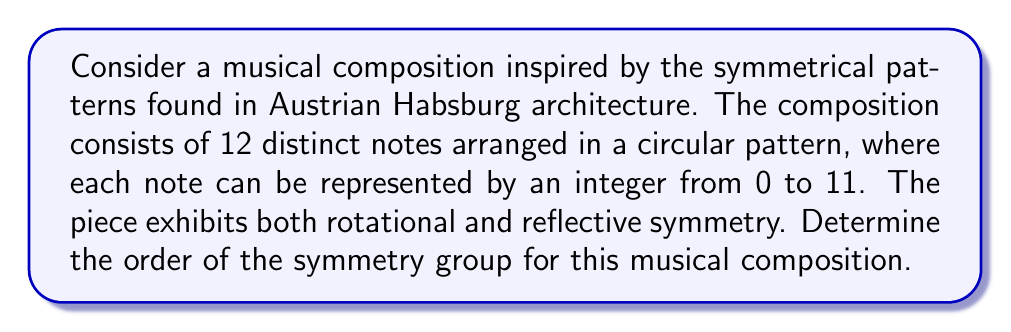Provide a solution to this math problem. Let's approach this step-by-step:

1) First, we need to identify the possible symmetries:

   a) Rotational symmetry: The composition can be rotated by multiples of $\frac{2\pi}{12} = \frac{\pi}{6}$ radians (or 30°).
   b) Reflective symmetry: The composition can be reflected across any of the 12 axes passing through a note and the center.

2) The rotational symmetries form a cyclic group of order 12, which we can denote as $C_{12}$.

3) The reflective symmetries form a group of order 12, as there are 12 possible axes of reflection.

4) The total symmetry group is the dihedral group $D_{12}$, which combines both rotations and reflections.

5) To calculate the order of $D_{12}$, we use the formula:

   $$|D_n| = 2n$$

   Where $n$ is the number of vertices (in this case, 12).

6) Therefore, the order of the symmetry group is:

   $$|D_{12}| = 2 \cdot 12 = 24$$

This means there are 24 distinct symmetry operations (including the identity) that can be applied to the musical composition while leaving it unchanged.
Answer: 24 